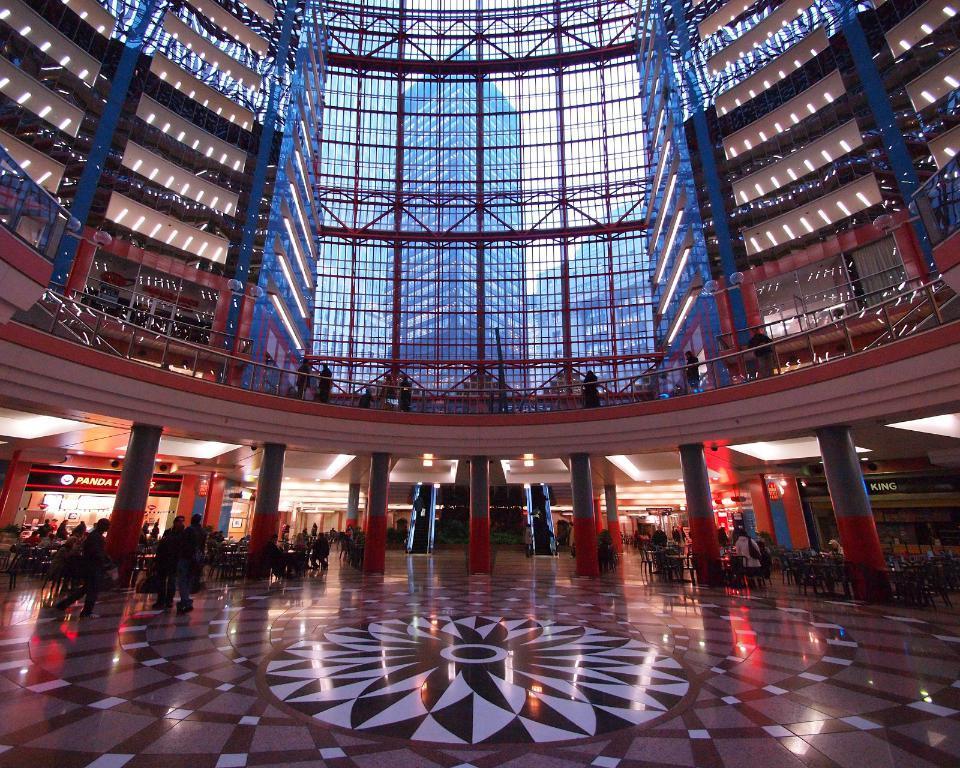Please provide a concise description of this image. In the foreground of this image, there is floor and we can also see two people walking and standing and also sitting on the chairs near table. There are pillars, walls, ceiling and lights of a building. In the background through the glass we can see buildings and the sky. 